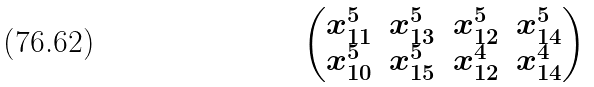<formula> <loc_0><loc_0><loc_500><loc_500>\begin{pmatrix} x _ { 1 1 } ^ { 5 } & x _ { 1 3 } ^ { 5 } & x _ { 1 2 } ^ { 5 } & x _ { 1 4 } ^ { 5 } \\ x _ { 1 0 } ^ { 5 } & x _ { 1 5 } ^ { 5 } & x _ { 1 2 } ^ { 4 } & x _ { 1 4 } ^ { 4 } \end{pmatrix}</formula> 